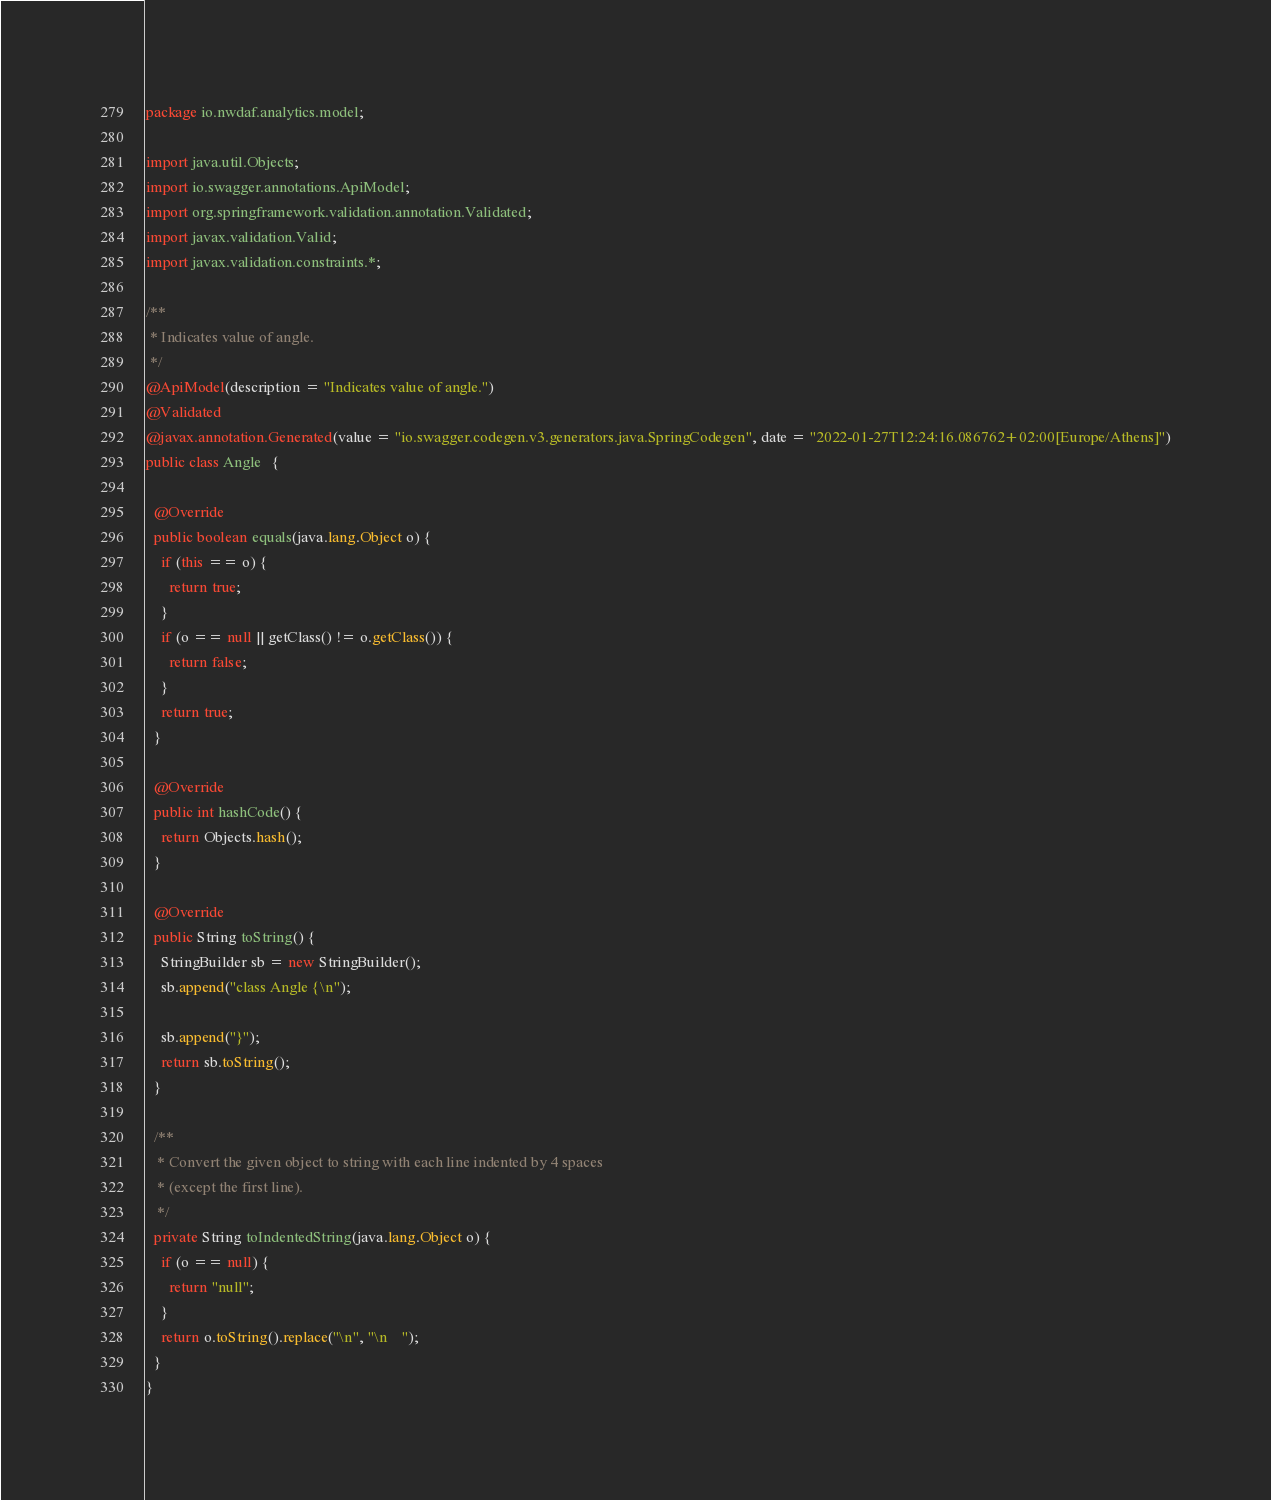Convert code to text. <code><loc_0><loc_0><loc_500><loc_500><_Java_>package io.nwdaf.analytics.model;

import java.util.Objects;
import io.swagger.annotations.ApiModel;
import org.springframework.validation.annotation.Validated;
import javax.validation.Valid;
import javax.validation.constraints.*;

/**
 * Indicates value of angle.
 */
@ApiModel(description = "Indicates value of angle.")
@Validated
@javax.annotation.Generated(value = "io.swagger.codegen.v3.generators.java.SpringCodegen", date = "2022-01-27T12:24:16.086762+02:00[Europe/Athens]")
public class Angle   {

  @Override
  public boolean equals(java.lang.Object o) {
    if (this == o) {
      return true;
    }
    if (o == null || getClass() != o.getClass()) {
      return false;
    }
    return true;
  }

  @Override
  public int hashCode() {
    return Objects.hash();
  }

  @Override
  public String toString() {
    StringBuilder sb = new StringBuilder();
    sb.append("class Angle {\n");
    
    sb.append("}");
    return sb.toString();
  }

  /**
   * Convert the given object to string with each line indented by 4 spaces
   * (except the first line).
   */
  private String toIndentedString(java.lang.Object o) {
    if (o == null) {
      return "null";
    }
    return o.toString().replace("\n", "\n    ");
  }
}
</code> 